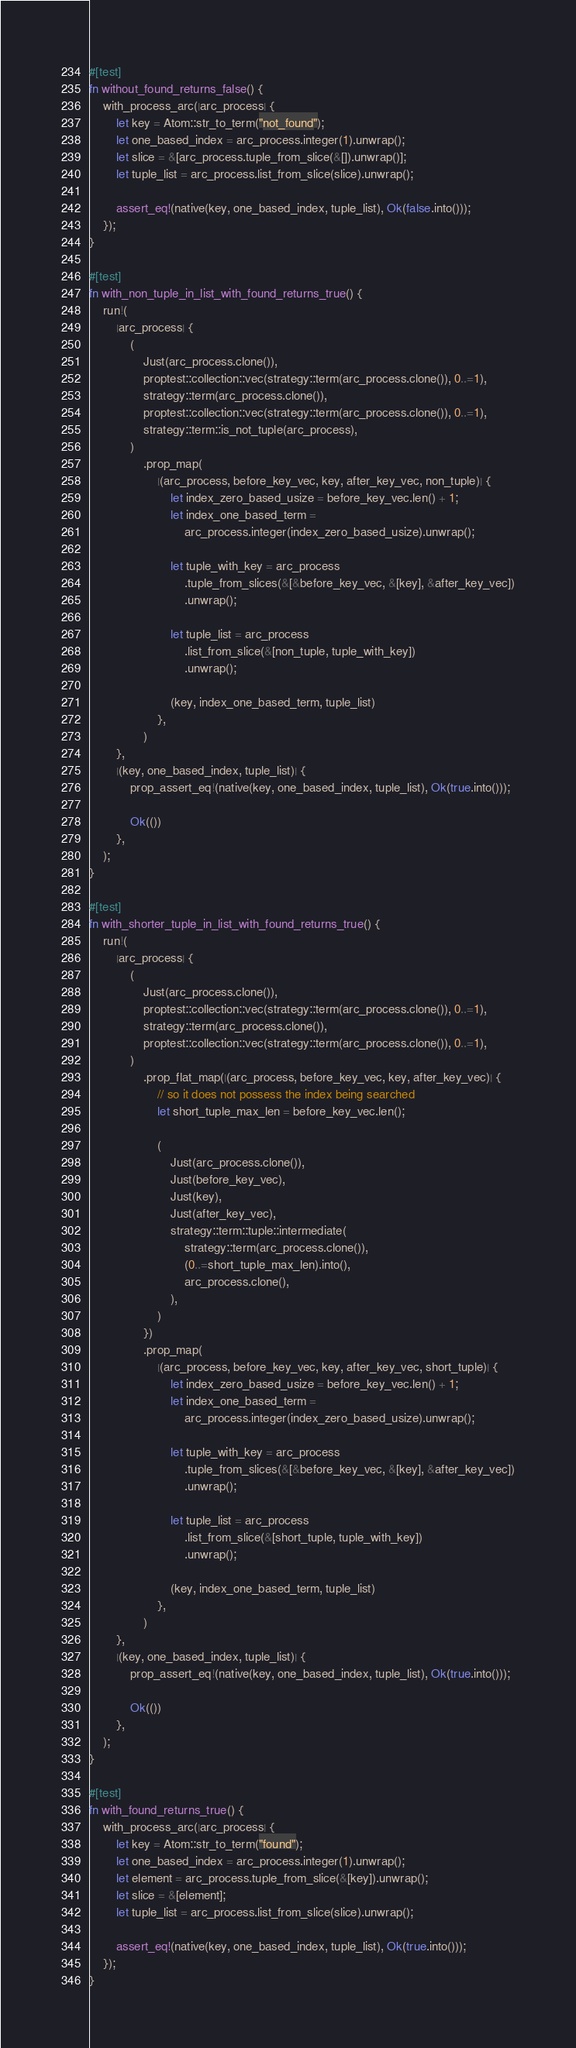Convert code to text. <code><loc_0><loc_0><loc_500><loc_500><_Rust_>#[test]
fn without_found_returns_false() {
    with_process_arc(|arc_process| {
        let key = Atom::str_to_term("not_found");
        let one_based_index = arc_process.integer(1).unwrap();
        let slice = &[arc_process.tuple_from_slice(&[]).unwrap()];
        let tuple_list = arc_process.list_from_slice(slice).unwrap();

        assert_eq!(native(key, one_based_index, tuple_list), Ok(false.into()));
    });
}

#[test]
fn with_non_tuple_in_list_with_found_returns_true() {
    run!(
        |arc_process| {
            (
                Just(arc_process.clone()),
                proptest::collection::vec(strategy::term(arc_process.clone()), 0..=1),
                strategy::term(arc_process.clone()),
                proptest::collection::vec(strategy::term(arc_process.clone()), 0..=1),
                strategy::term::is_not_tuple(arc_process),
            )
                .prop_map(
                    |(arc_process, before_key_vec, key, after_key_vec, non_tuple)| {
                        let index_zero_based_usize = before_key_vec.len() + 1;
                        let index_one_based_term =
                            arc_process.integer(index_zero_based_usize).unwrap();

                        let tuple_with_key = arc_process
                            .tuple_from_slices(&[&before_key_vec, &[key], &after_key_vec])
                            .unwrap();

                        let tuple_list = arc_process
                            .list_from_slice(&[non_tuple, tuple_with_key])
                            .unwrap();

                        (key, index_one_based_term, tuple_list)
                    },
                )
        },
        |(key, one_based_index, tuple_list)| {
            prop_assert_eq!(native(key, one_based_index, tuple_list), Ok(true.into()));

            Ok(())
        },
    );
}

#[test]
fn with_shorter_tuple_in_list_with_found_returns_true() {
    run!(
        |arc_process| {
            (
                Just(arc_process.clone()),
                proptest::collection::vec(strategy::term(arc_process.clone()), 0..=1),
                strategy::term(arc_process.clone()),
                proptest::collection::vec(strategy::term(arc_process.clone()), 0..=1),
            )
                .prop_flat_map(|(arc_process, before_key_vec, key, after_key_vec)| {
                    // so it does not possess the index being searched
                    let short_tuple_max_len = before_key_vec.len();

                    (
                        Just(arc_process.clone()),
                        Just(before_key_vec),
                        Just(key),
                        Just(after_key_vec),
                        strategy::term::tuple::intermediate(
                            strategy::term(arc_process.clone()),
                            (0..=short_tuple_max_len).into(),
                            arc_process.clone(),
                        ),
                    )
                })
                .prop_map(
                    |(arc_process, before_key_vec, key, after_key_vec, short_tuple)| {
                        let index_zero_based_usize = before_key_vec.len() + 1;
                        let index_one_based_term =
                            arc_process.integer(index_zero_based_usize).unwrap();

                        let tuple_with_key = arc_process
                            .tuple_from_slices(&[&before_key_vec, &[key], &after_key_vec])
                            .unwrap();

                        let tuple_list = arc_process
                            .list_from_slice(&[short_tuple, tuple_with_key])
                            .unwrap();

                        (key, index_one_based_term, tuple_list)
                    },
                )
        },
        |(key, one_based_index, tuple_list)| {
            prop_assert_eq!(native(key, one_based_index, tuple_list), Ok(true.into()));

            Ok(())
        },
    );
}

#[test]
fn with_found_returns_true() {
    with_process_arc(|arc_process| {
        let key = Atom::str_to_term("found");
        let one_based_index = arc_process.integer(1).unwrap();
        let element = arc_process.tuple_from_slice(&[key]).unwrap();
        let slice = &[element];
        let tuple_list = arc_process.list_from_slice(slice).unwrap();

        assert_eq!(native(key, one_based_index, tuple_list), Ok(true.into()));
    });
}
</code> 